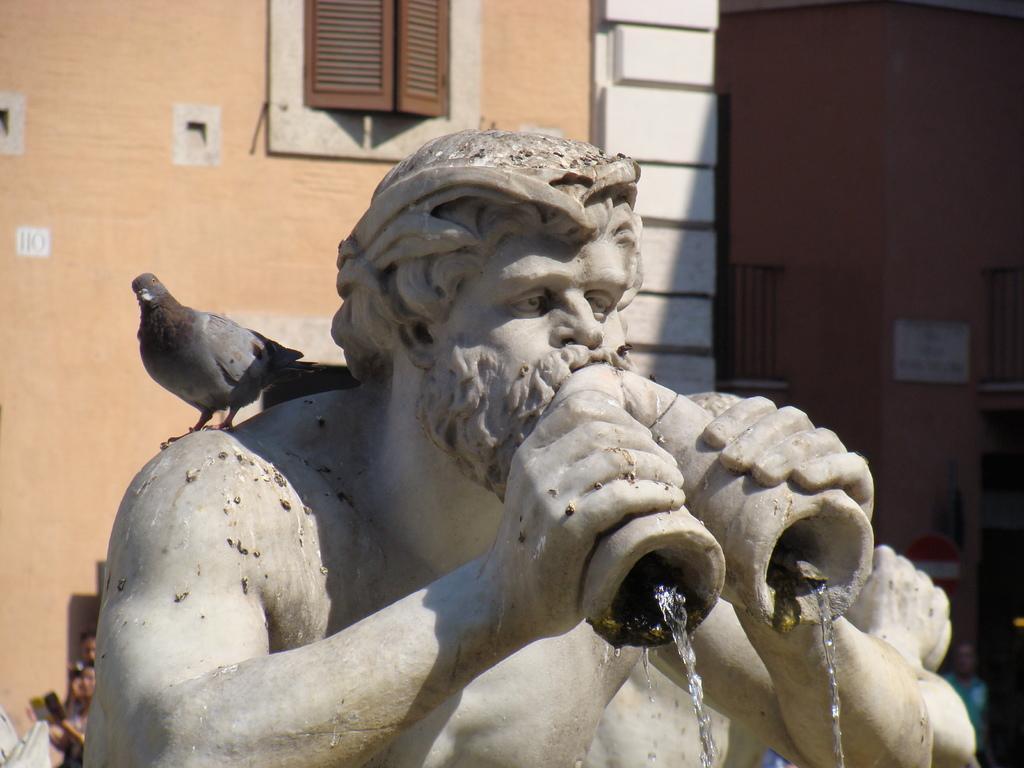Please provide a concise description of this image. In this image we can see a statue. From the statue water is coming. On the statue there is a bird. In the back there is a building with window. 